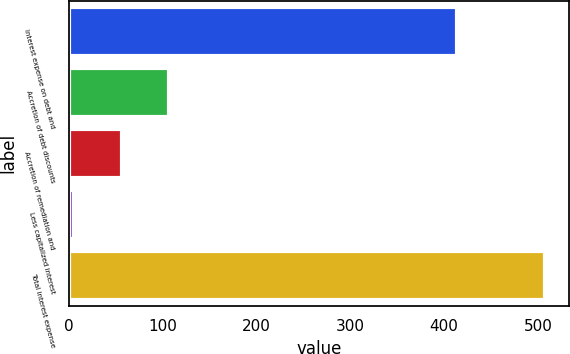Convert chart. <chart><loc_0><loc_0><loc_500><loc_500><bar_chart><fcel>Interest expense on debt and<fcel>Accretion of debt discounts<fcel>Accretion of remediation and<fcel>Less capitalized interest<fcel>Total interest expense<nl><fcel>413.2<fcel>106.52<fcel>56.41<fcel>6.3<fcel>507.4<nl></chart> 